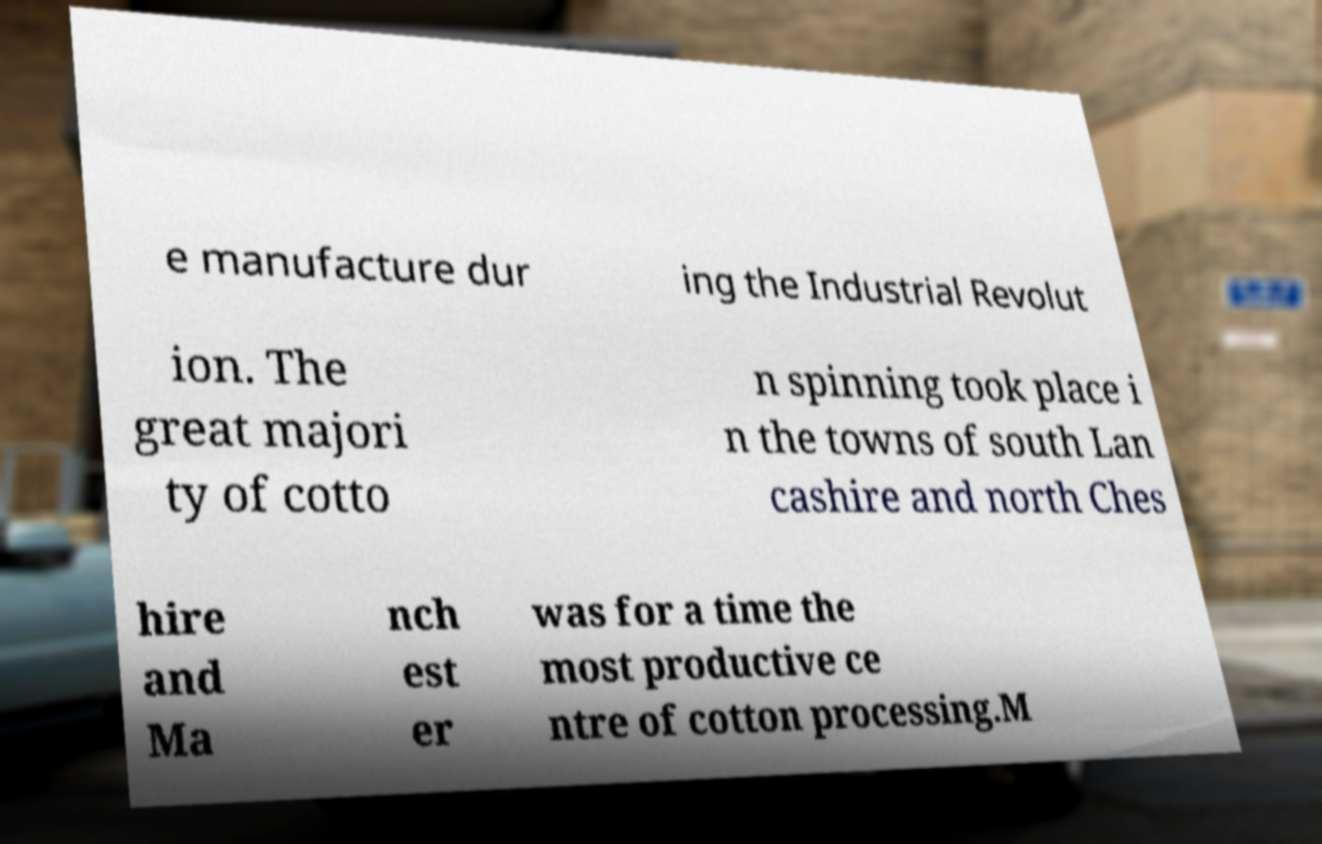For documentation purposes, I need the text within this image transcribed. Could you provide that? e manufacture dur ing the Industrial Revolut ion. The great majori ty of cotto n spinning took place i n the towns of south Lan cashire and north Ches hire and Ma nch est er was for a time the most productive ce ntre of cotton processing.M 